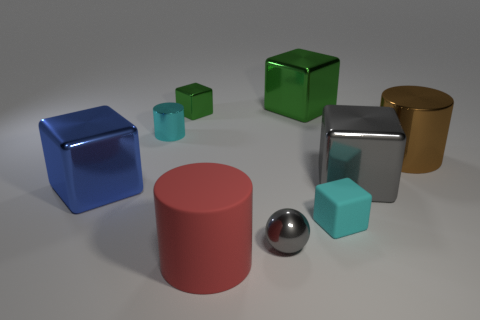Subtract 2 cubes. How many cubes are left? 3 Subtract all rubber blocks. How many blocks are left? 4 Subtract all blue blocks. How many blocks are left? 4 Add 1 tiny red cubes. How many objects exist? 10 Subtract all cyan blocks. Subtract all gray balls. How many blocks are left? 4 Subtract all balls. How many objects are left? 8 Add 5 small shiny cubes. How many small shiny cubes exist? 6 Subtract 0 brown cubes. How many objects are left? 9 Subtract all purple matte cylinders. Subtract all small cyan metal objects. How many objects are left? 8 Add 3 metallic balls. How many metallic balls are left? 4 